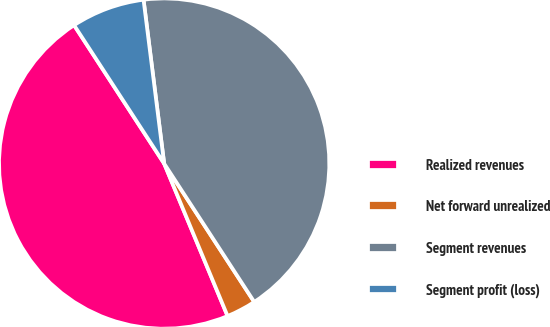Convert chart. <chart><loc_0><loc_0><loc_500><loc_500><pie_chart><fcel>Realized revenues<fcel>Net forward unrealized<fcel>Segment revenues<fcel>Segment profit (loss)<nl><fcel>47.09%<fcel>2.91%<fcel>42.81%<fcel>7.19%<nl></chart> 